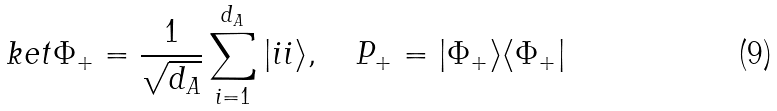Convert formula to latex. <formula><loc_0><loc_0><loc_500><loc_500>\ k e t { \Phi _ { + } } = \frac { 1 } { \sqrt { d _ { A } } } \sum _ { i = 1 } ^ { d _ { A } } | i i \rangle , \quad P _ { + } = | \Phi _ { + } \rangle \langle \Phi _ { + } |</formula> 